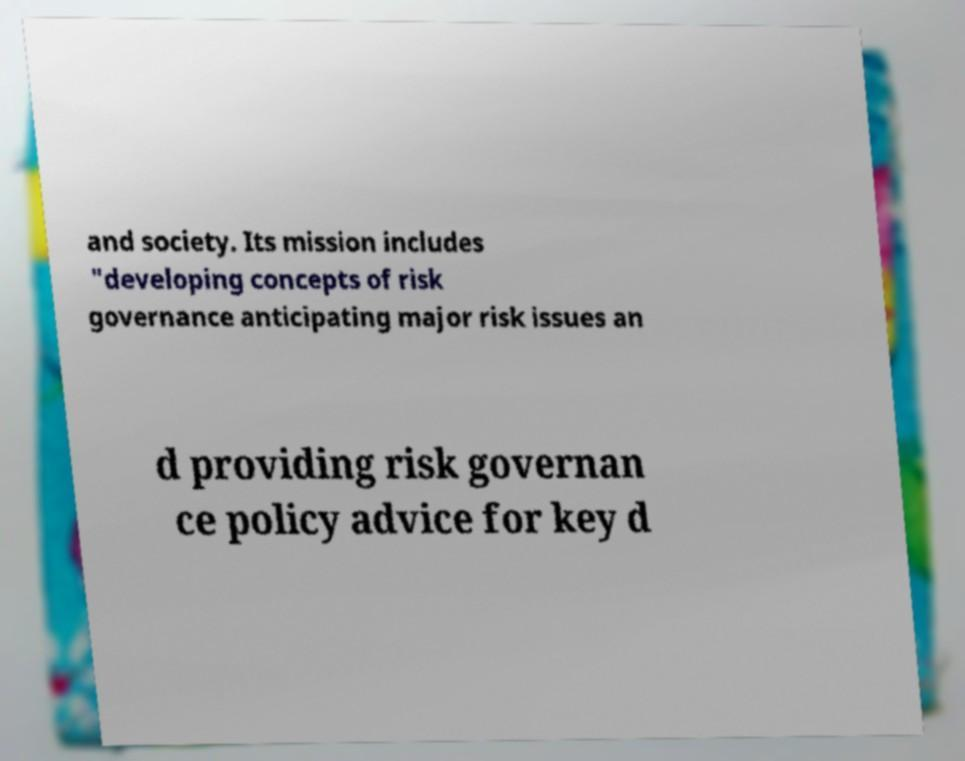There's text embedded in this image that I need extracted. Can you transcribe it verbatim? and society. Its mission includes "developing concepts of risk governance anticipating major risk issues an d providing risk governan ce policy advice for key d 